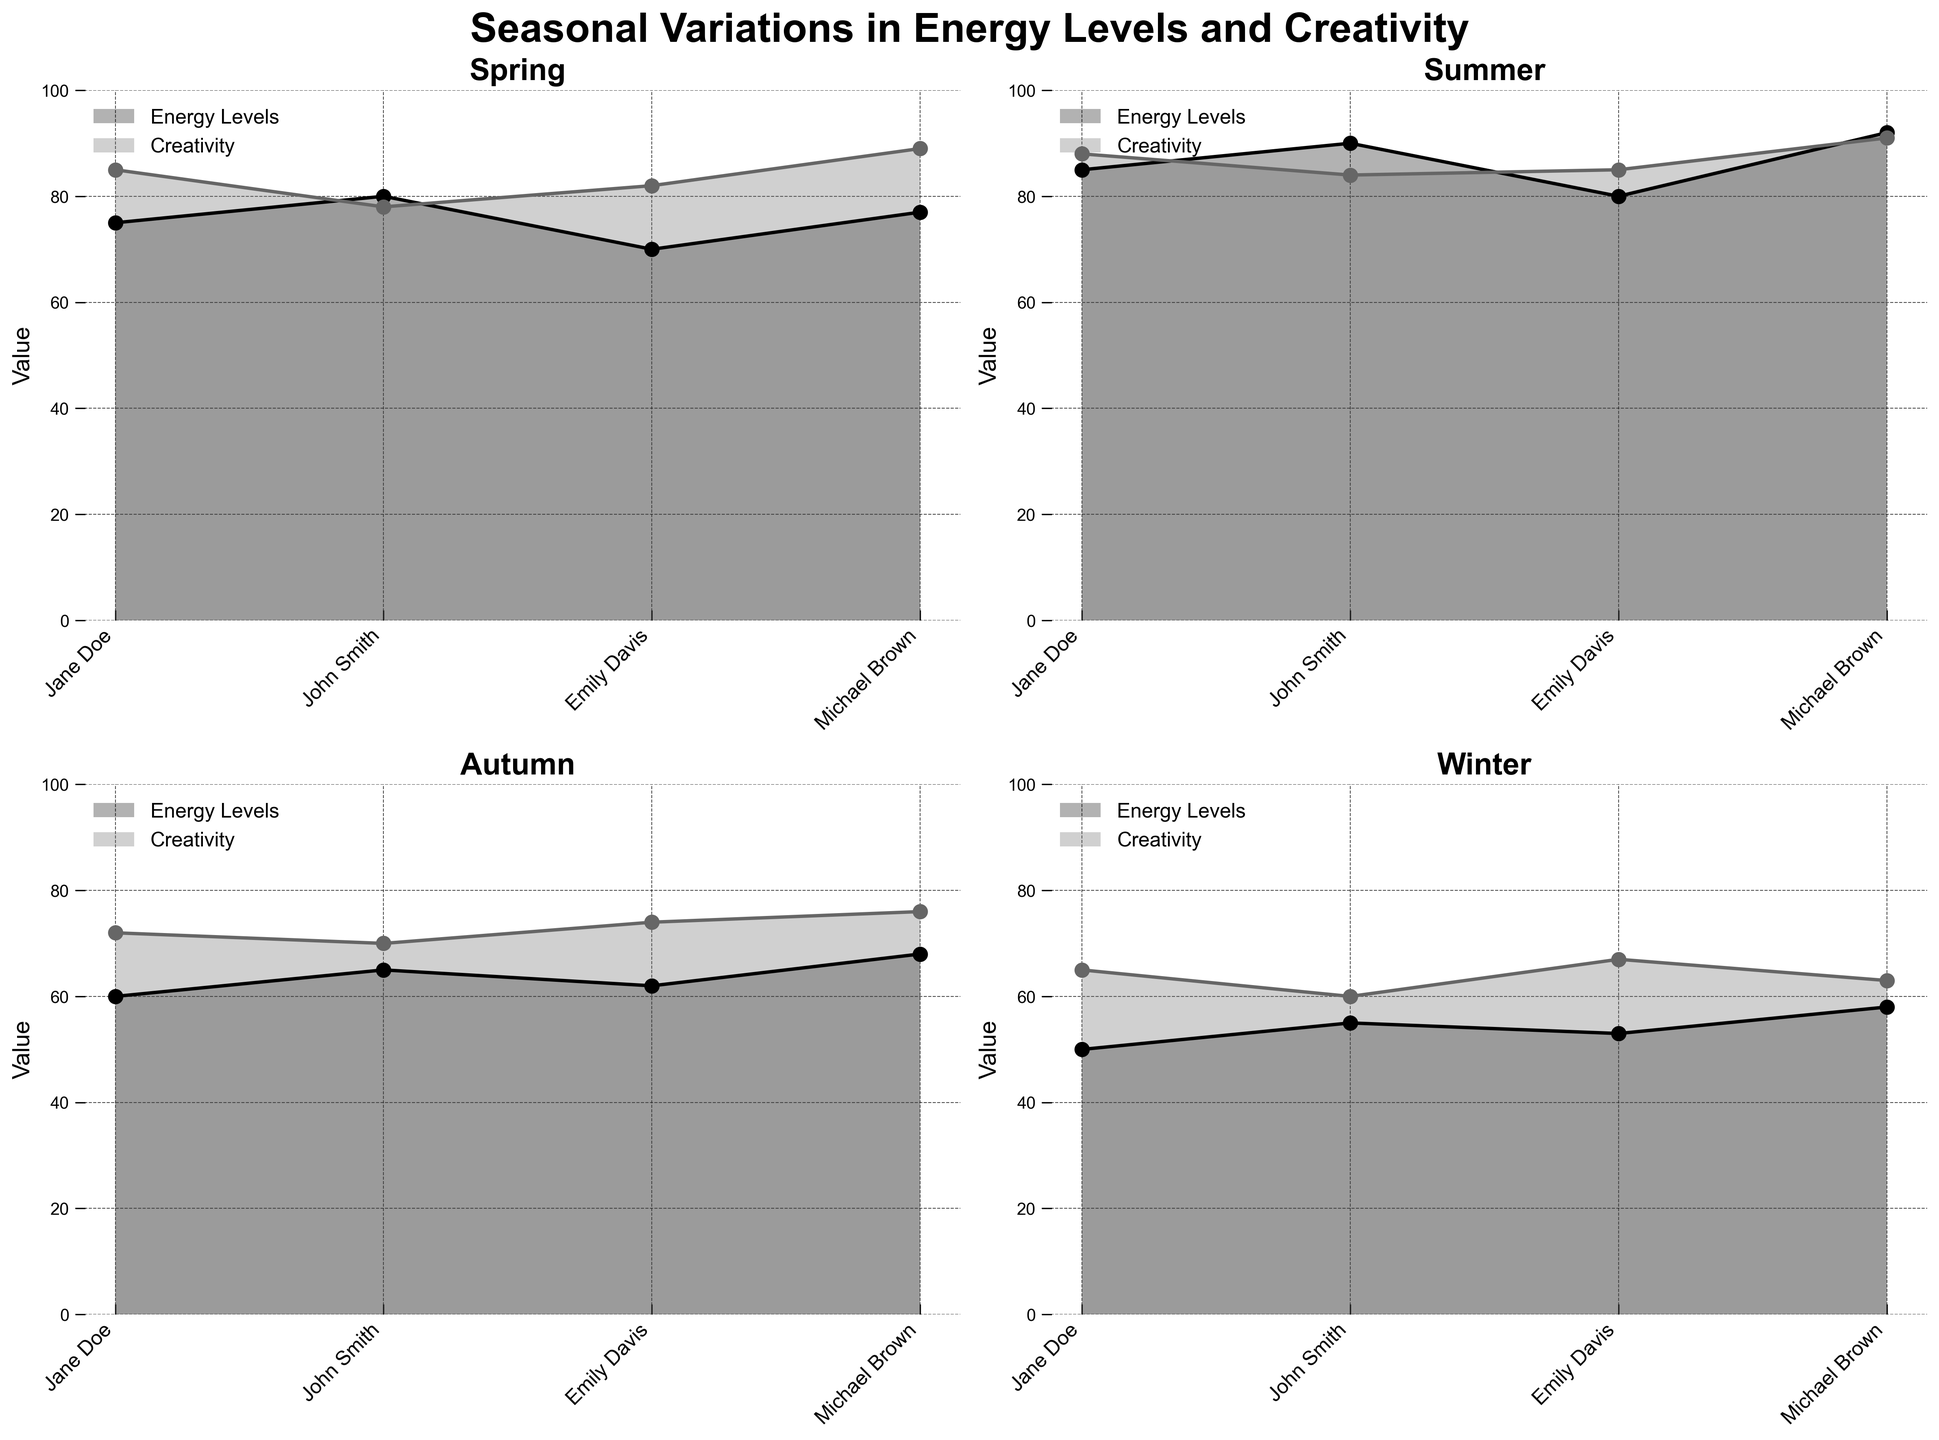What is the title of the chart? The title is located at the top of the chart, written in bold font.
Answer: Seasonal Variations in Energy Levels and Creativity Which season has the highest Energy Levels for John Smith? By observing the subplot for each season, looking at the line representing John Smith's energy levels in each, the highest value is found in Summer.
Answer: Summer During which season does Jane Doe exhibit the lowest Creativity levels? By examining the Creativity values for Jane Doe across the subplots for all seasons, the lowest value appears in Winter.
Answer: Winter How do Energy Levels compare between Michael Brown and Emily Davis in Spring? By observing the Spring subplot and comparing the Energy Levels lines for Michael Brown and Emily Davis, Michael Brown has 77 and Emily Davis has 70.
Answer: Michael Brown has higher Which season shows the most significant drop in Energy Levels for Emily Davis compared to Summer? First, identify Emily Davis's Energy Levels in Summer (80). Next, check her values in other seasons: Spring (70), Autumn (62), Winter (53). The greatest drop is from Summer to Winter (80 to 53).
Answer: Winter What is the average Creativity value for John Smith across all seasons? Collect John Smith's Creativity values: Spring (78), Summer (84), Autumn (70), Winter (60). Calculate the average: (78 + 84 + 70 + 60) / 4 = 73
Answer: 73 Is there a season where all individuals have higher Energy Levels compared to their Creativity levels? Compare each individual's Energy Levels and Creativity values within each season. In Summer, all individuals have higher Energy Levels compared to their Creativity levels.
Answer: Summer Identify the season with the smallest range in Creativity levels for the group. Calculate the range for Creativity levels in each season:
Spring: 89-78 = 11,
Summer: 91-84 = 7,
Autumn: 76-70 = 6,
Winter: 67-60 = 7.
The smallest range is in Autumn.
Answer: Autumn Which season does Michael Brown show the highest contrast between Energy Levels and Creativity? For each season, find the difference between Michael Brown's Energy Levels and Creativity:
Spring: 77 - 89 = -12,
Summer: 92 - 91 = 1,
Autumn: 68 - 76 = -8,
Winter: 58 - 63 = -5.
The highest contrast is in Spring.
Answer: Spring 